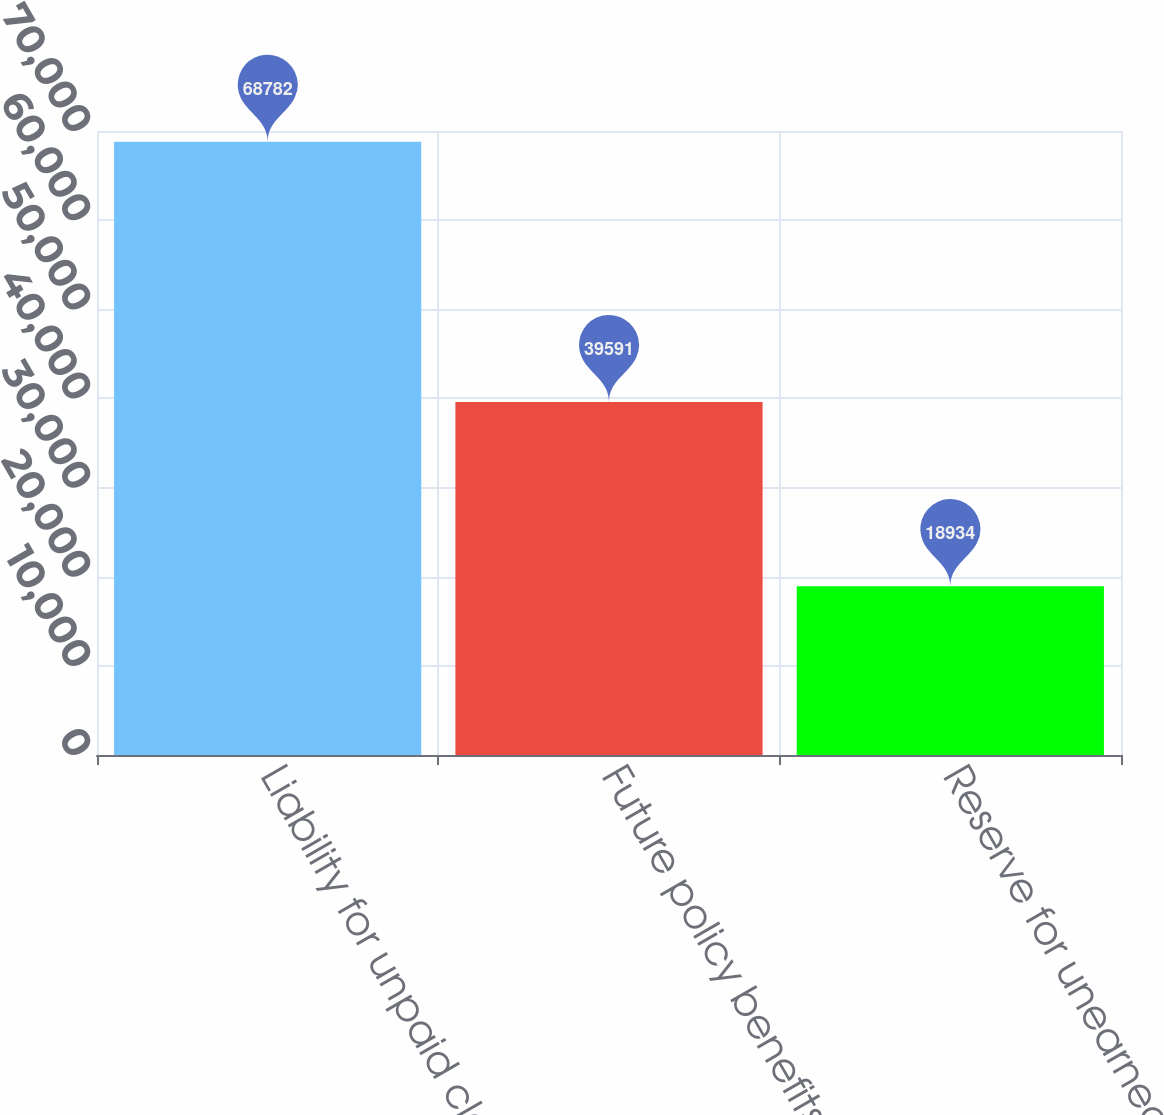Convert chart. <chart><loc_0><loc_0><loc_500><loc_500><bar_chart><fcel>Liability for unpaid claims<fcel>Future policy benefits for<fcel>Reserve for unearned premiums<nl><fcel>68782<fcel>39591<fcel>18934<nl></chart> 